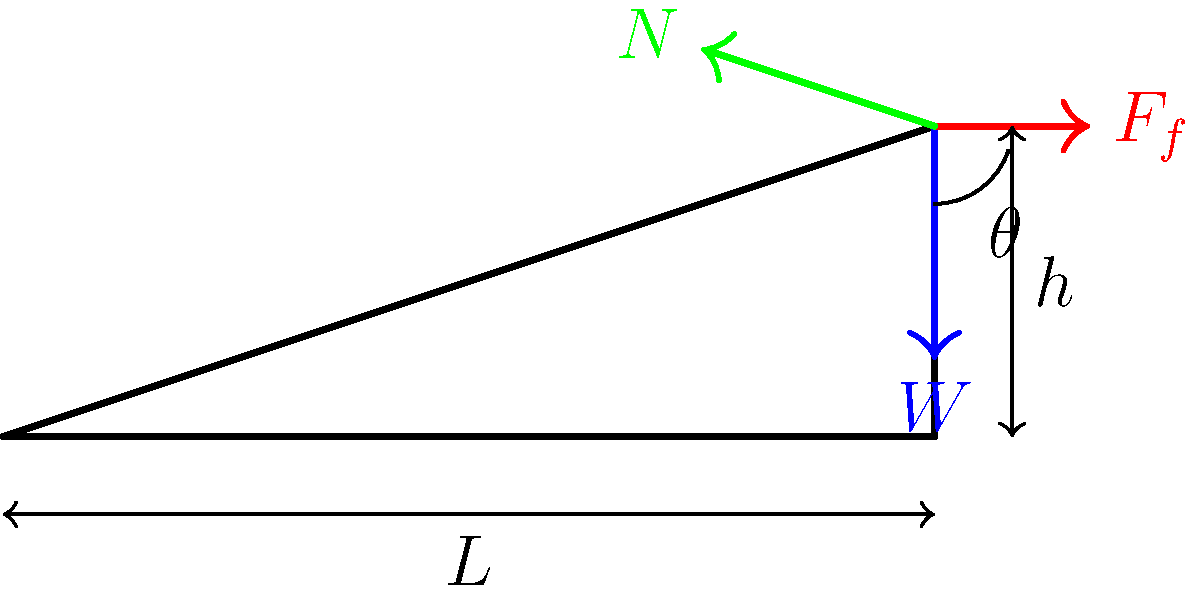As a community organizer working with CPS parents, you're advocating for better accessibility in schools. You're discussing a wheelchair ramp design with an engineer. The ramp has a length $L$ of 6 meters and a height $h$ of 2 meters. If a wheelchair and its user have a combined weight $W$ of 1200 N, what is the magnitude of the normal force $N$ exerted by the ramp on the wheelchair? Let's approach this step-by-step:

1) First, we need to find the angle of inclination $\theta$ of the ramp:
   $\tan \theta = \frac{h}{L} = \frac{2}{6} = \frac{1}{3}$
   $\theta = \arctan(\frac{1}{3}) \approx 18.4°$

2) In a force diagram for an object on an inclined plane, the normal force $N$ is perpendicular to the ramp surface.

3) The relationship between the weight $W$ and the normal force $N$ is:
   $N = W \cos \theta$

4) We know $W = 1200$ N, so we can substitute this into our equation:
   $N = 1200 \cos \theta$

5) Now we can calculate the value of $N$:
   $N = 1200 \cos(18.4°)$
   $N \approx 1200 \times 0.9492$
   $N \approx 1139$ N

Therefore, the magnitude of the normal force $N$ is approximately 1139 N.
Answer: 1139 N 